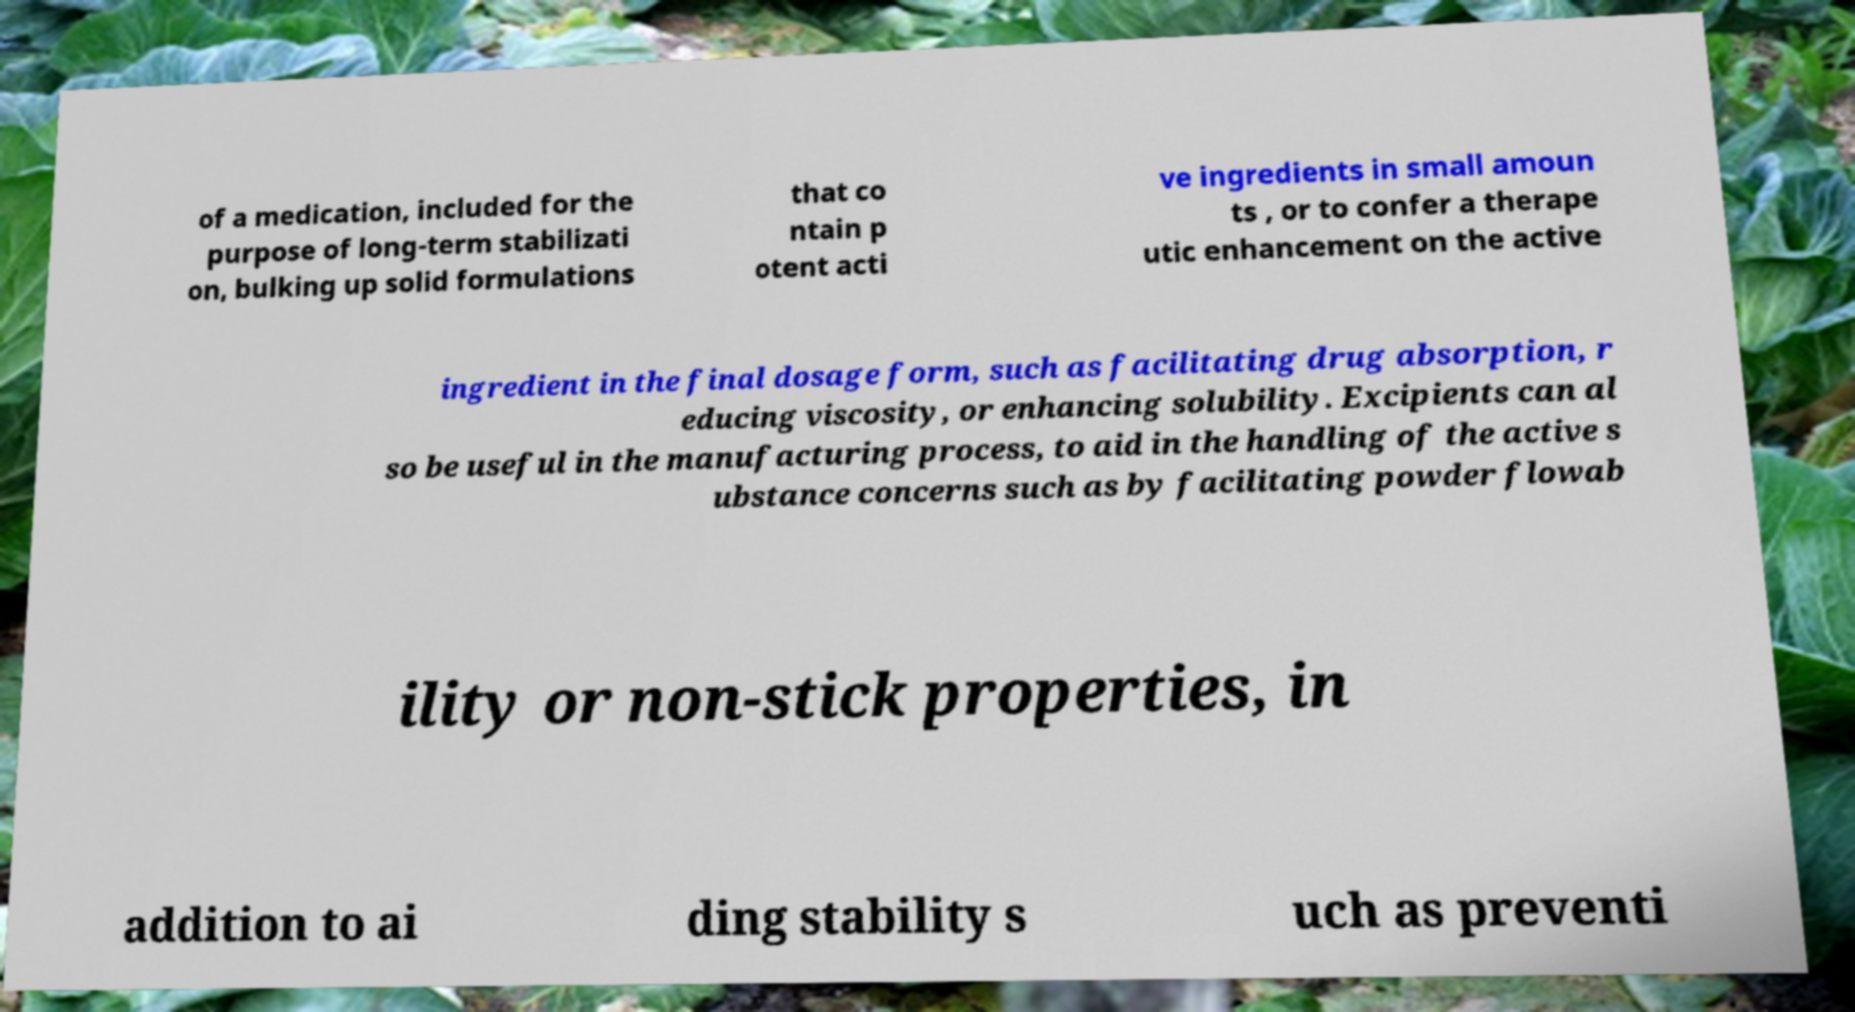Could you extract and type out the text from this image? of a medication, included for the purpose of long-term stabilizati on, bulking up solid formulations that co ntain p otent acti ve ingredients in small amoun ts , or to confer a therape utic enhancement on the active ingredient in the final dosage form, such as facilitating drug absorption, r educing viscosity, or enhancing solubility. Excipients can al so be useful in the manufacturing process, to aid in the handling of the active s ubstance concerns such as by facilitating powder flowab ility or non-stick properties, in addition to ai ding stability s uch as preventi 